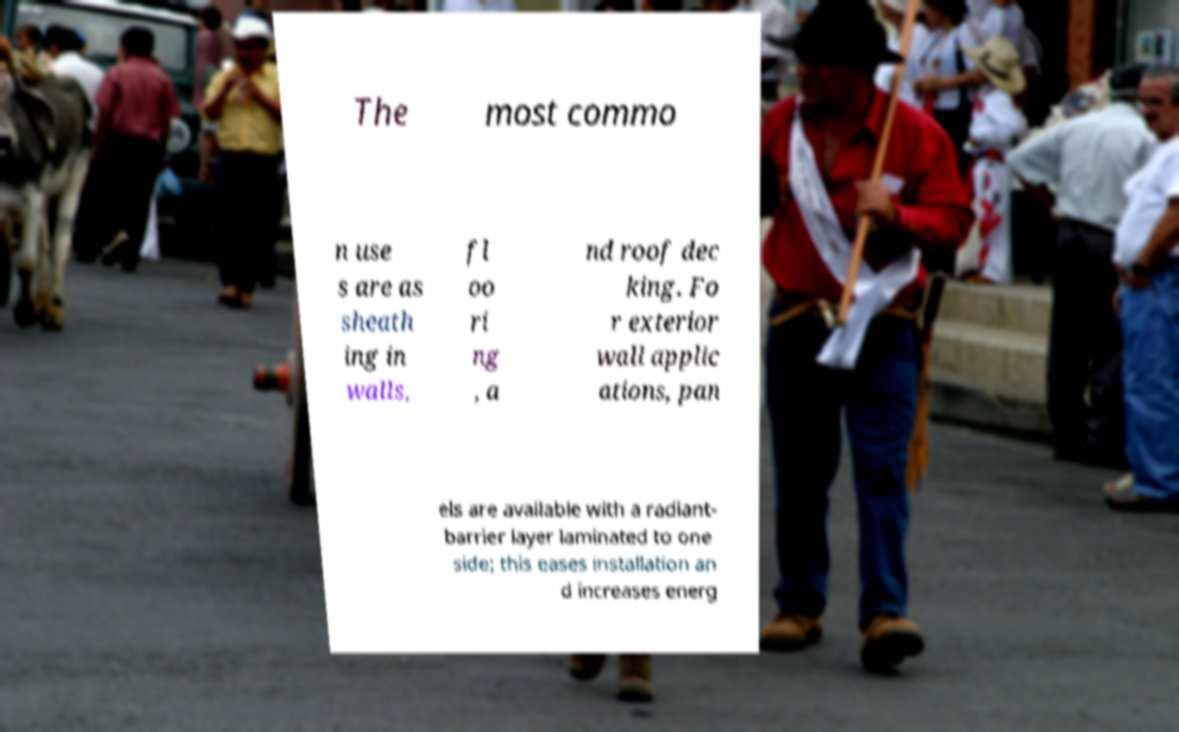Please read and relay the text visible in this image. What does it say? The most commo n use s are as sheath ing in walls, fl oo ri ng , a nd roof dec king. Fo r exterior wall applic ations, pan els are available with a radiant- barrier layer laminated to one side; this eases installation an d increases energ 